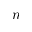<formula> <loc_0><loc_0><loc_500><loc_500>n</formula> 